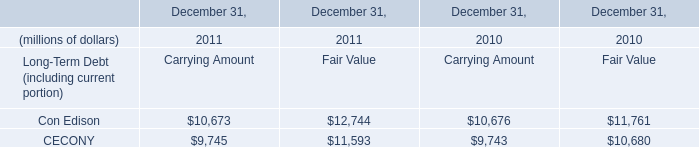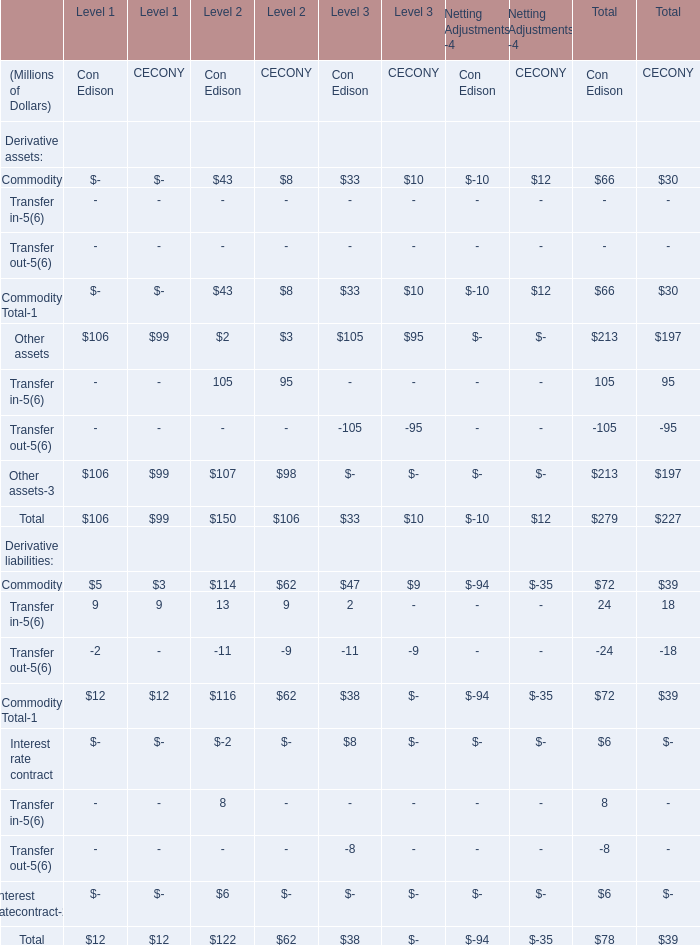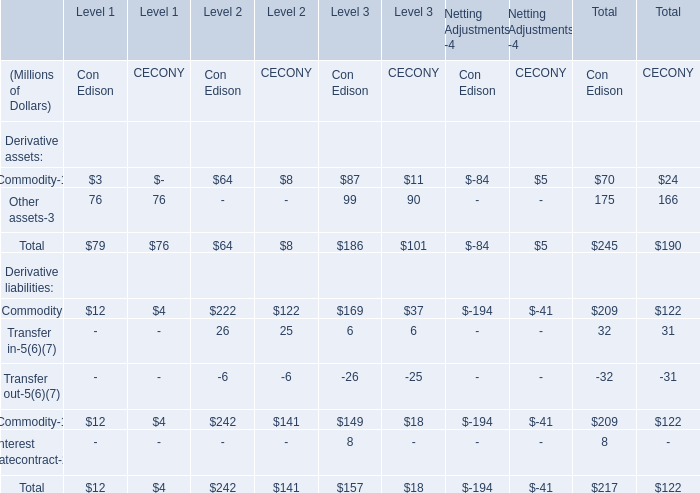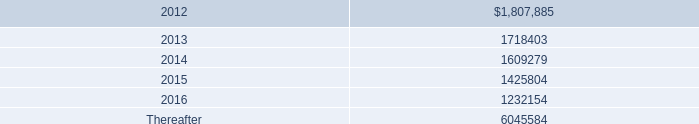percentage rentals based on tenants 2019 sales totaled how much for the years ended december 31 , 2011 and 2010 , in thousands? 
Computations: (8482000 + 7912000)
Answer: 16394000.0. 